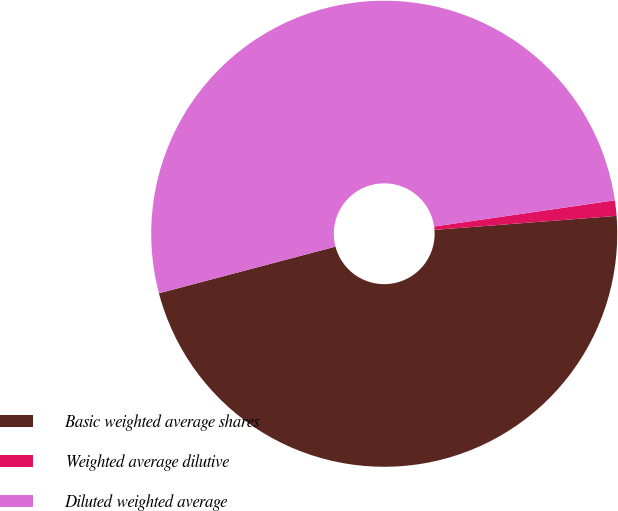Convert chart. <chart><loc_0><loc_0><loc_500><loc_500><pie_chart><fcel>Basic weighted average shares<fcel>Weighted average dilutive<fcel>Diluted weighted average<nl><fcel>47.11%<fcel>1.07%<fcel>51.82%<nl></chart> 